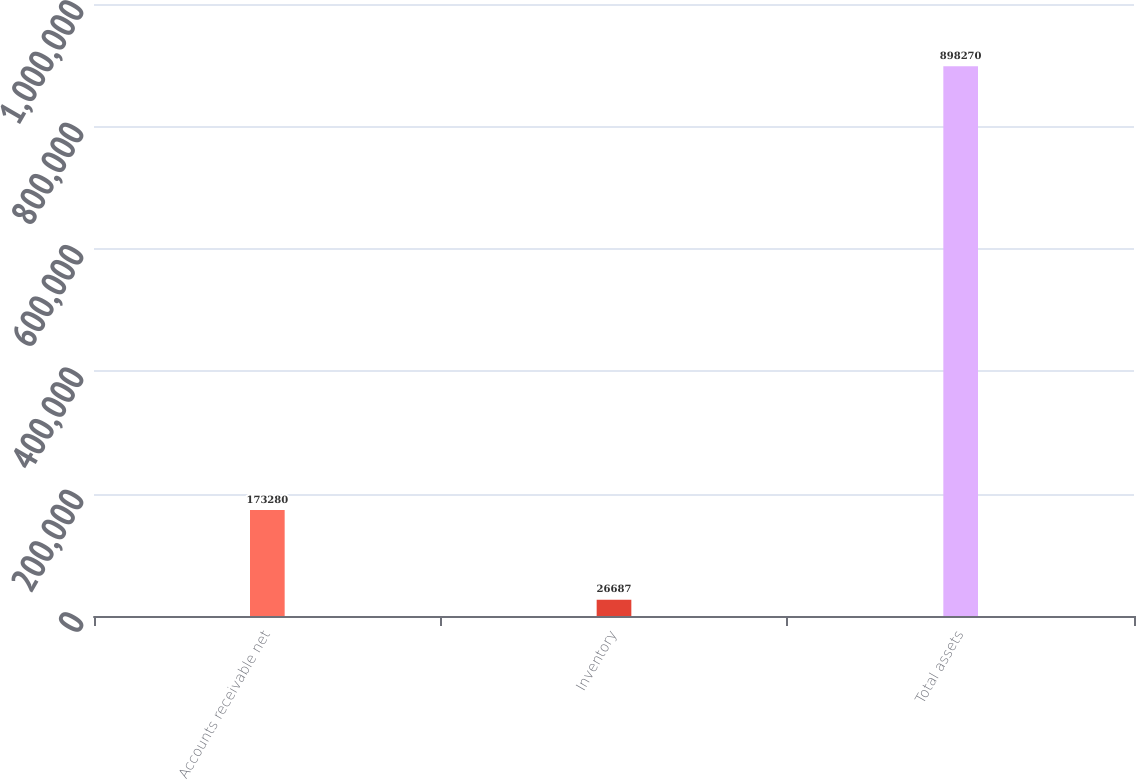Convert chart to OTSL. <chart><loc_0><loc_0><loc_500><loc_500><bar_chart><fcel>Accounts receivable net<fcel>Inventory<fcel>Total assets<nl><fcel>173280<fcel>26687<fcel>898270<nl></chart> 